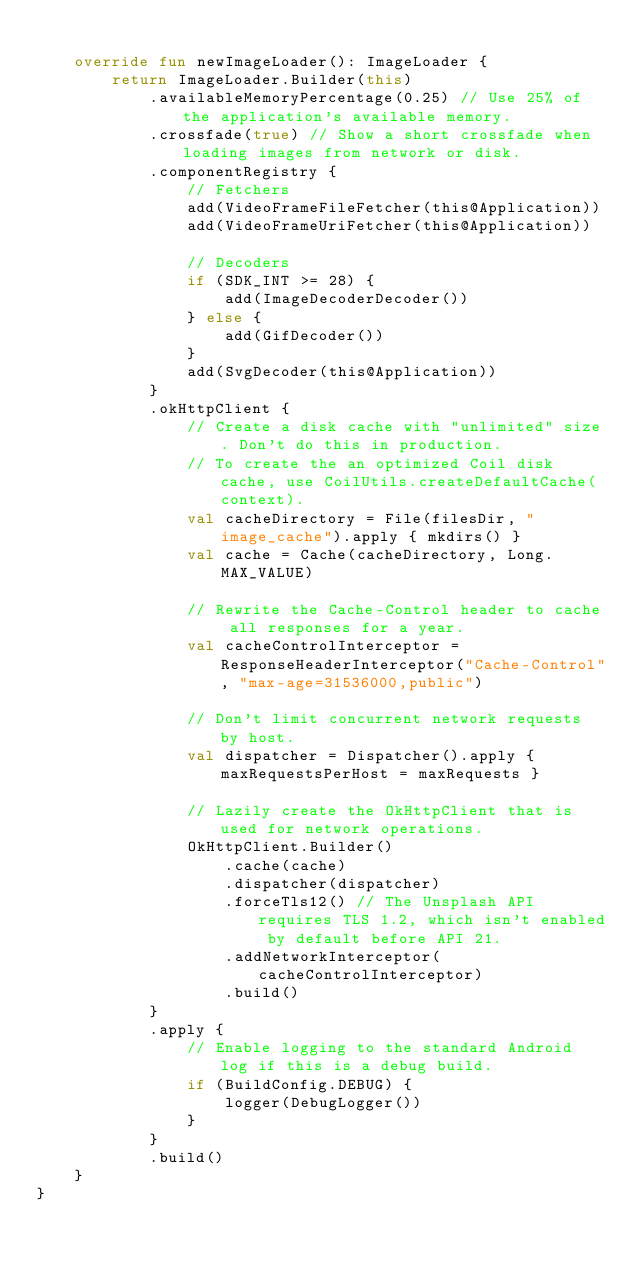<code> <loc_0><loc_0><loc_500><loc_500><_Kotlin_>
    override fun newImageLoader(): ImageLoader {
        return ImageLoader.Builder(this)
            .availableMemoryPercentage(0.25) // Use 25% of the application's available memory.
            .crossfade(true) // Show a short crossfade when loading images from network or disk.
            .componentRegistry {
                // Fetchers
                add(VideoFrameFileFetcher(this@Application))
                add(VideoFrameUriFetcher(this@Application))

                // Decoders
                if (SDK_INT >= 28) {
                    add(ImageDecoderDecoder())
                } else {
                    add(GifDecoder())
                }
                add(SvgDecoder(this@Application))
            }
            .okHttpClient {
                // Create a disk cache with "unlimited" size. Don't do this in production.
                // To create the an optimized Coil disk cache, use CoilUtils.createDefaultCache(context).
                val cacheDirectory = File(filesDir, "image_cache").apply { mkdirs() }
                val cache = Cache(cacheDirectory, Long.MAX_VALUE)

                // Rewrite the Cache-Control header to cache all responses for a year.
                val cacheControlInterceptor = ResponseHeaderInterceptor("Cache-Control", "max-age=31536000,public")

                // Don't limit concurrent network requests by host.
                val dispatcher = Dispatcher().apply { maxRequestsPerHost = maxRequests }

                // Lazily create the OkHttpClient that is used for network operations.
                OkHttpClient.Builder()
                    .cache(cache)
                    .dispatcher(dispatcher)
                    .forceTls12() // The Unsplash API requires TLS 1.2, which isn't enabled by default before API 21.
                    .addNetworkInterceptor(cacheControlInterceptor)
                    .build()
            }
            .apply {
                // Enable logging to the standard Android log if this is a debug build.
                if (BuildConfig.DEBUG) {
                    logger(DebugLogger())
                }
            }
            .build()
    }
}
</code> 